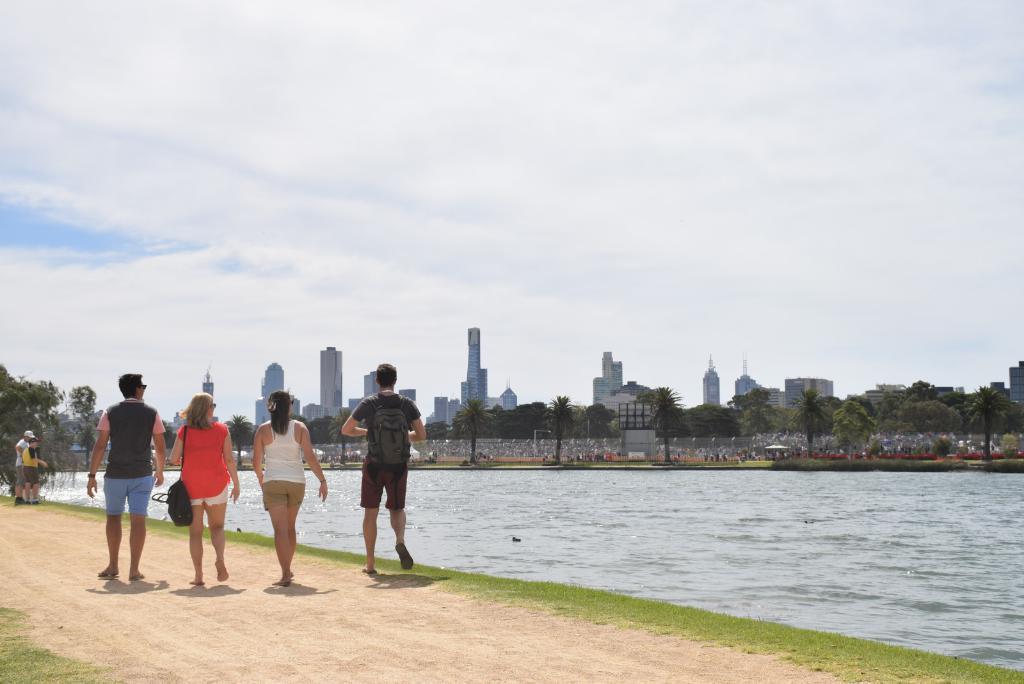How would you summarize this image in a sentence or two? In this image, there are a few people, trees, buildings. We can see the ground with some objects. We can also see some grass and some water. We can see the fence and the sky with clouds. 